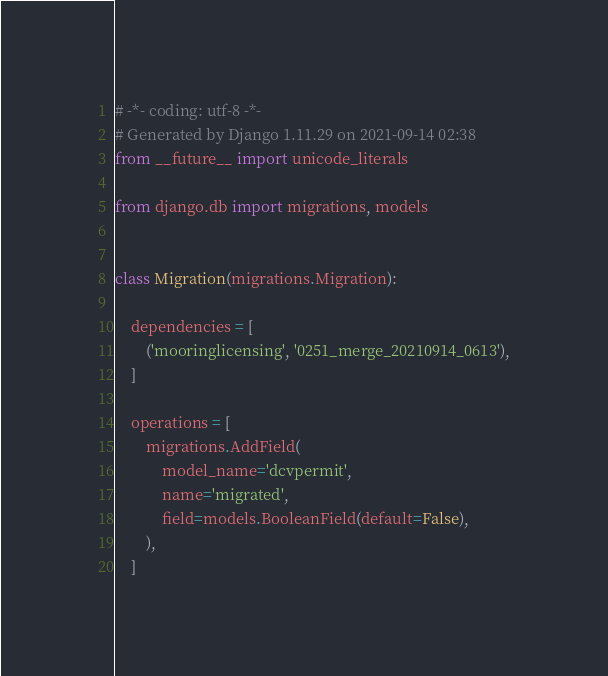<code> <loc_0><loc_0><loc_500><loc_500><_Python_># -*- coding: utf-8 -*-
# Generated by Django 1.11.29 on 2021-09-14 02:38
from __future__ import unicode_literals

from django.db import migrations, models


class Migration(migrations.Migration):

    dependencies = [
        ('mooringlicensing', '0251_merge_20210914_0613'),
    ]

    operations = [
        migrations.AddField(
            model_name='dcvpermit',
            name='migrated',
            field=models.BooleanField(default=False),
        ),
    ]
</code> 